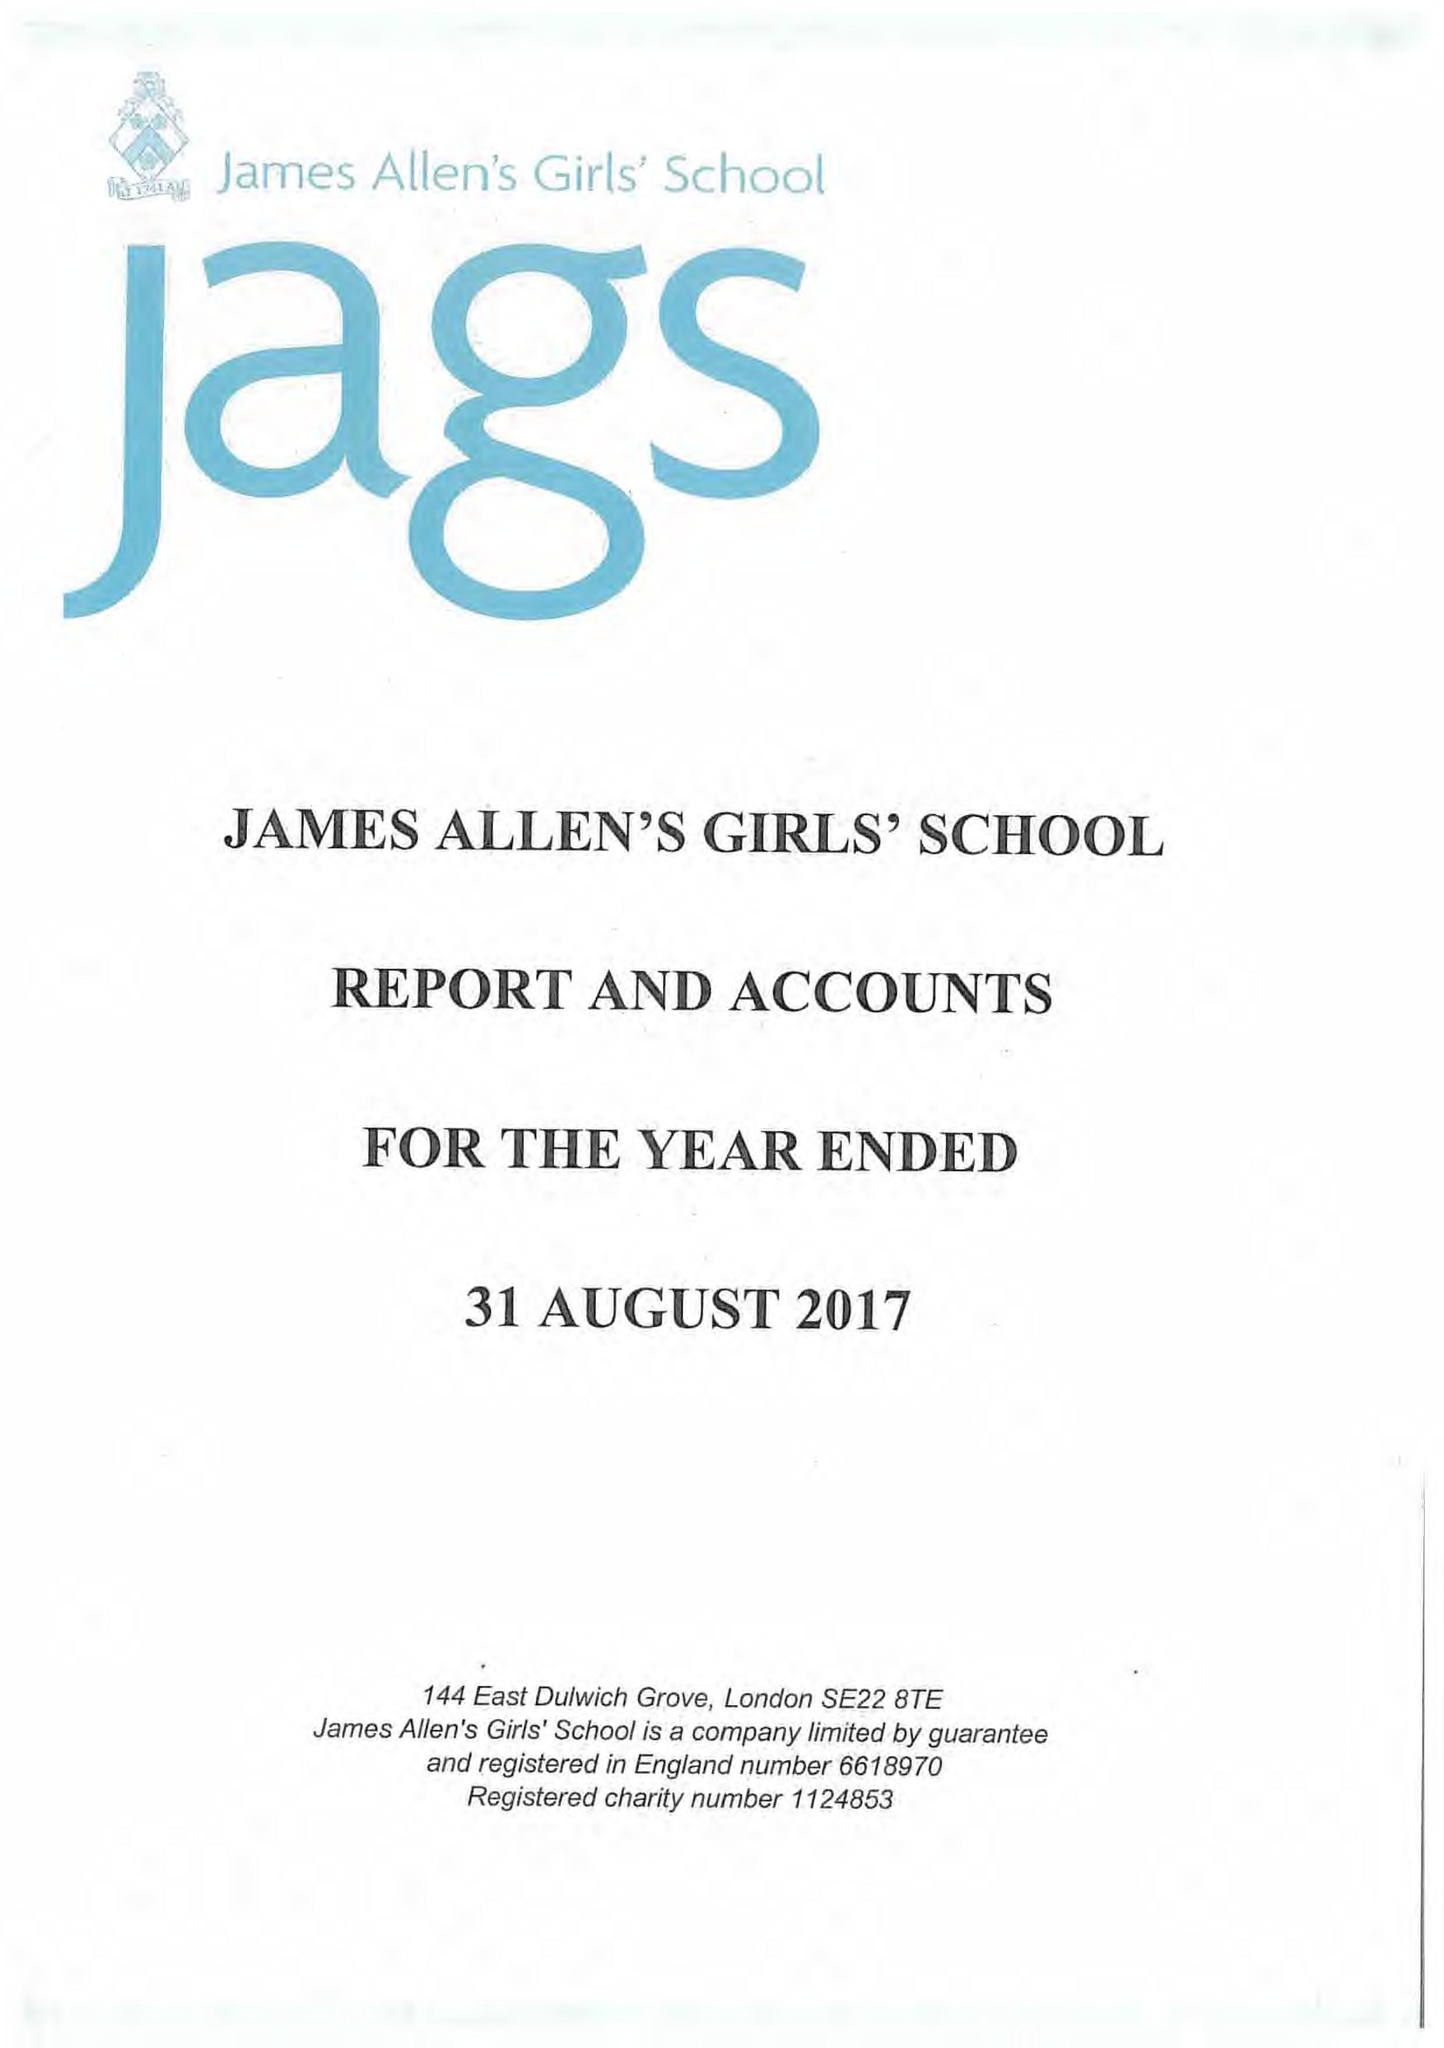What is the value for the spending_annually_in_british_pounds?
Answer the question using a single word or phrase. 20128770.00 